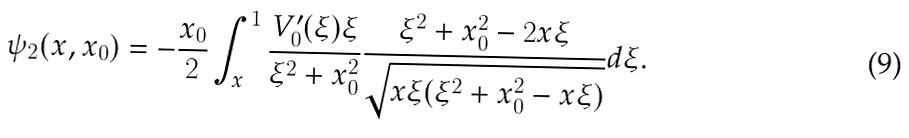<formula> <loc_0><loc_0><loc_500><loc_500>\psi _ { 2 } ( x , x _ { 0 } ) = - \frac { x _ { 0 } } { 2 } \int _ { x } ^ { 1 } \frac { V _ { 0 } ^ { \prime } ( \xi ) \xi } { \xi ^ { 2 } + x _ { 0 } ^ { 2 } } \frac { \xi ^ { 2 } + x _ { 0 } ^ { 2 } - 2 x \xi } { \sqrt { x \xi ( \xi ^ { 2 } + x _ { 0 } ^ { 2 } - x \xi ) } } d \xi .</formula> 